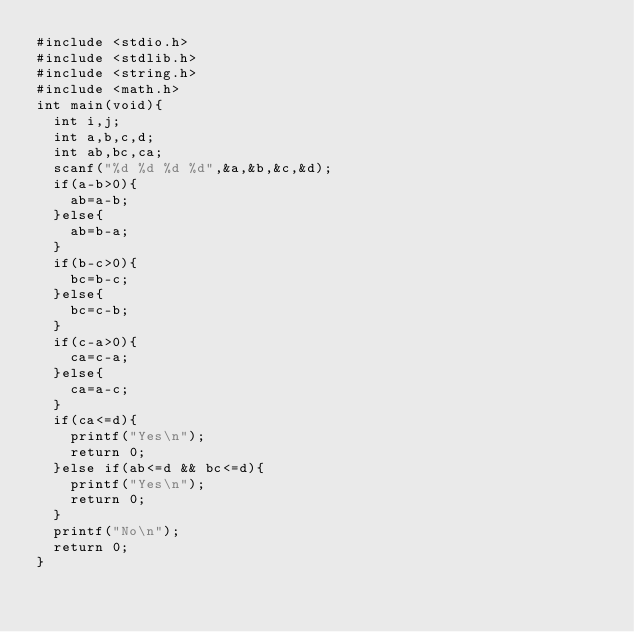<code> <loc_0><loc_0><loc_500><loc_500><_C_>#include <stdio.h>
#include <stdlib.h>
#include <string.h>
#include <math.h>
int main(void){
  int i,j;
  int a,b,c,d;
  int ab,bc,ca;
  scanf("%d %d %d %d",&a,&b,&c,&d);
  if(a-b>0){
    ab=a-b;
  }else{
    ab=b-a;
  }
  if(b-c>0){
    bc=b-c;
  }else{
    bc=c-b;
  }
  if(c-a>0){
    ca=c-a;
  }else{
    ca=a-c;
  }
  if(ca<=d){
    printf("Yes\n");
    return 0;
  }else if(ab<=d && bc<=d){
    printf("Yes\n");
    return 0;
  }
  printf("No\n");
  return 0;
}
</code> 